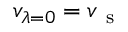<formula> <loc_0><loc_0><loc_500><loc_500>v _ { \lambda = 0 } = v _ { s }</formula> 